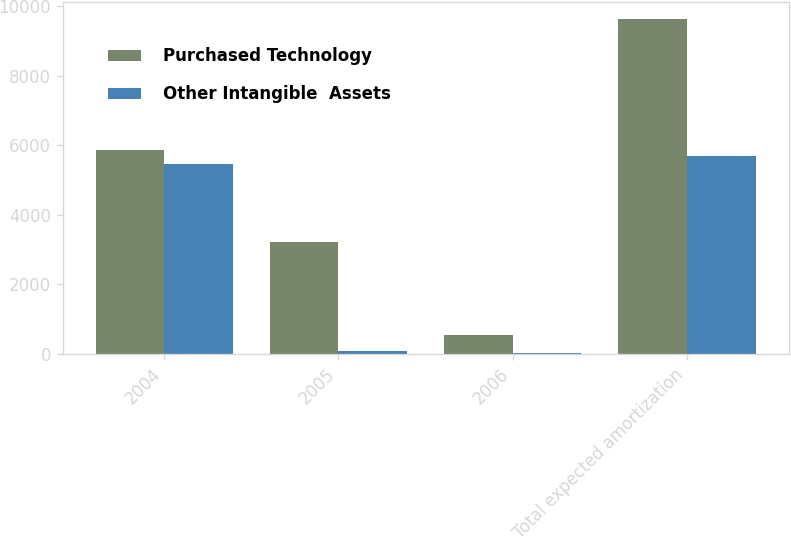Convert chart to OTSL. <chart><loc_0><loc_0><loc_500><loc_500><stacked_bar_chart><ecel><fcel>2004<fcel>2005<fcel>2006<fcel>Total expected amortization<nl><fcel>Purchased Technology<fcel>5873<fcel>3214<fcel>547<fcel>9634<nl><fcel>Other Intangible  Assets<fcel>5462<fcel>80<fcel>17<fcel>5684<nl></chart> 